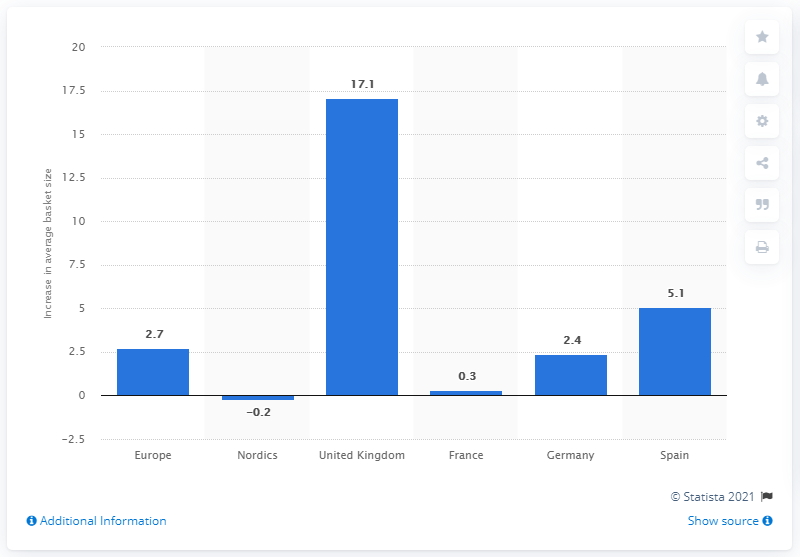Draw attention to some important aspects in this diagram. In the UK, the average basket size increased by 17.1% from 2015 to 2016. 